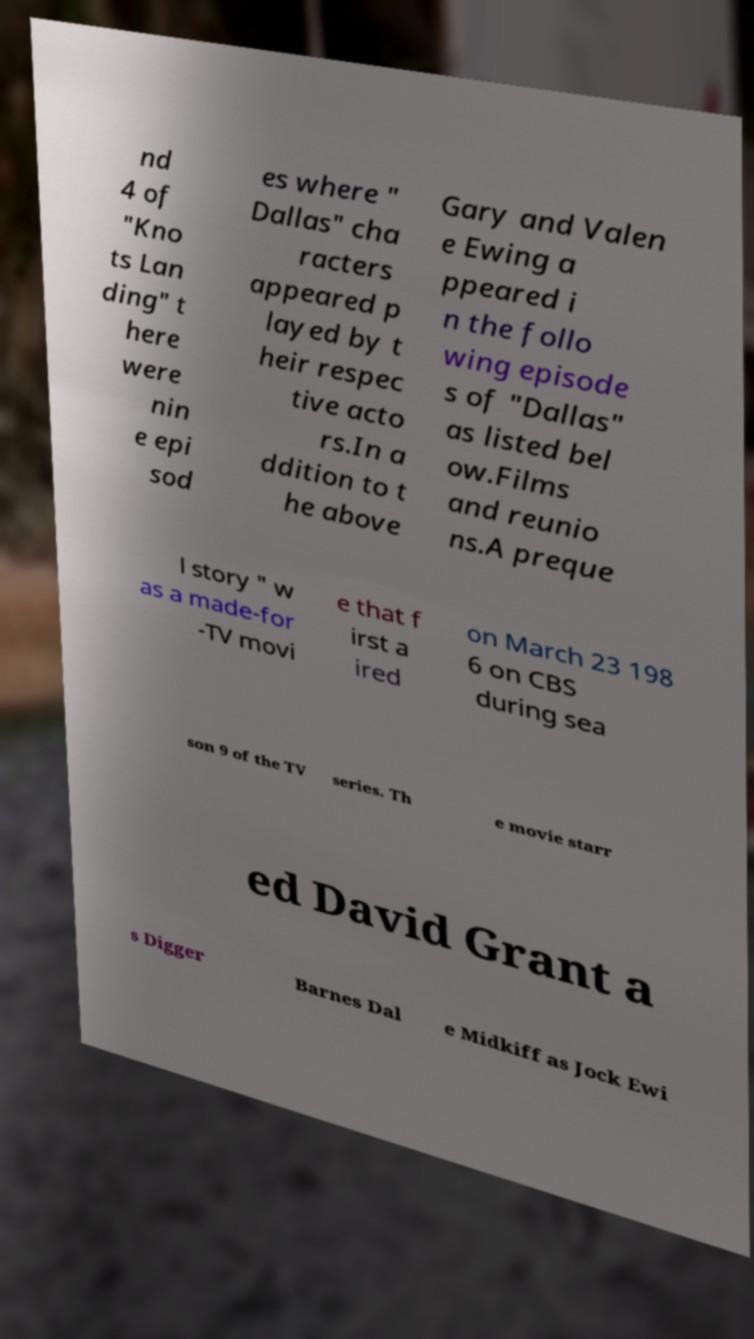For documentation purposes, I need the text within this image transcribed. Could you provide that? nd 4 of "Kno ts Lan ding" t here were nin e epi sod es where " Dallas" cha racters appeared p layed by t heir respec tive acto rs.In a ddition to t he above Gary and Valen e Ewing a ppeared i n the follo wing episode s of "Dallas" as listed bel ow.Films and reunio ns.A preque l story " w as a made-for -TV movi e that f irst a ired on March 23 198 6 on CBS during sea son 9 of the TV series. Th e movie starr ed David Grant a s Digger Barnes Dal e Midkiff as Jock Ewi 